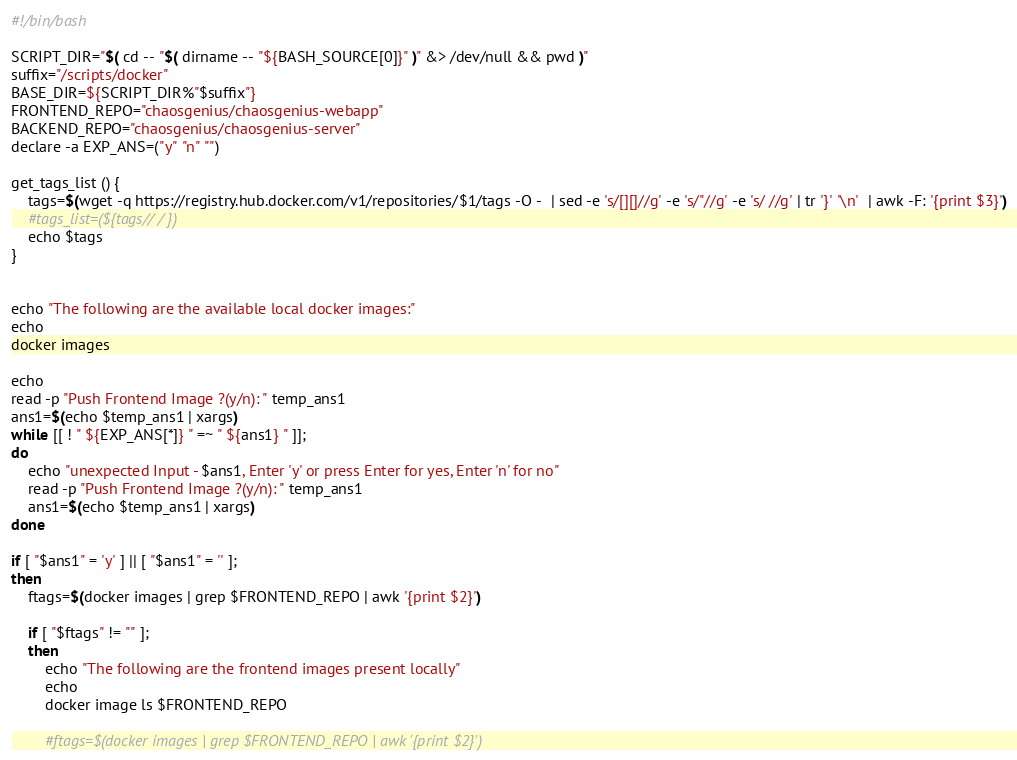Convert code to text. <code><loc_0><loc_0><loc_500><loc_500><_Bash_>#!/bin/bash

SCRIPT_DIR="$( cd -- "$( dirname -- "${BASH_SOURCE[0]}" )" &> /dev/null && pwd )"
suffix="/scripts/docker"
BASE_DIR=${SCRIPT_DIR%"$suffix"}
FRONTEND_REPO="chaosgenius/chaosgenius-webapp"
BACKEND_REPO="chaosgenius/chaosgenius-server"
declare -a EXP_ANS=("y" "n" "")

get_tags_list () {
    tags=$(wget -q https://registry.hub.docker.com/v1/repositories/$1/tags -O -  | sed -e 's/[][]//g' -e 's/"//g' -e 's/ //g' | tr '}' '\n'  | awk -F: '{print $3}')
    #tags_list=(${tags// / })
    echo $tags
}


echo "The following are the available local docker images:"
echo
docker images 

echo
read -p "Push Frontend Image ?(y/n): " temp_ans1
ans1=$(echo $temp_ans1 | xargs)
while [[ ! " ${EXP_ANS[*]} " =~ " ${ans1} " ]];
do
    echo "unexpected Input - $ans1, Enter 'y' or press Enter for yes, Enter 'n' for no"
    read -p "Push Frontend Image ?(y/n): " temp_ans1
    ans1=$(echo $temp_ans1 | xargs)
done

if [ "$ans1" = 'y' ] || [ "$ans1" = '' ];
then
    ftags=$(docker images | grep $FRONTEND_REPO | awk '{print $2}')
    
    if [ "$ftags" != "" ];
    then
        echo "The following are the frontend images present locally"
        echo
        docker image ls $FRONTEND_REPO
    
        #ftags=$(docker images | grep $FRONTEND_REPO | awk '{print $2}')</code> 